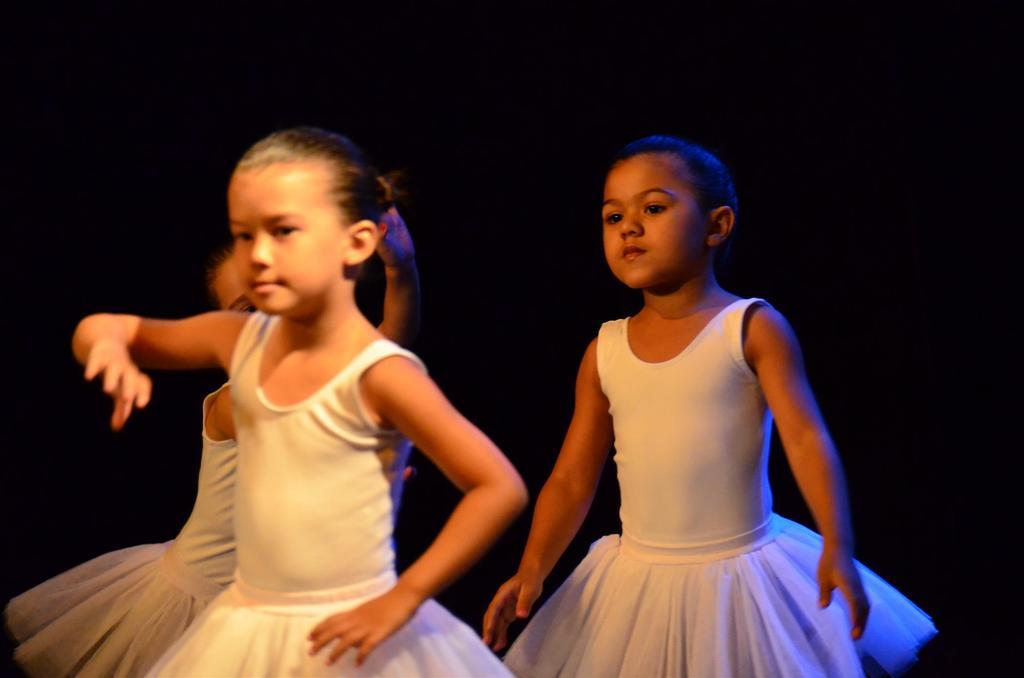How many people are in the image? There are three girls in the image. What are the girls wearing? The girls are wearing white dresses. What are the girls doing in the image? The girls are performing. What can be seen in the background of the image? The background of the image has a dark view. What type of design can be seen on the bread in the image? There is no bread present in the image, so no design can be observed. What kind of apparatus is being used by the girls in the image? The provided facts do not mention any specific apparatus being used by the girls; they are simply performing. 